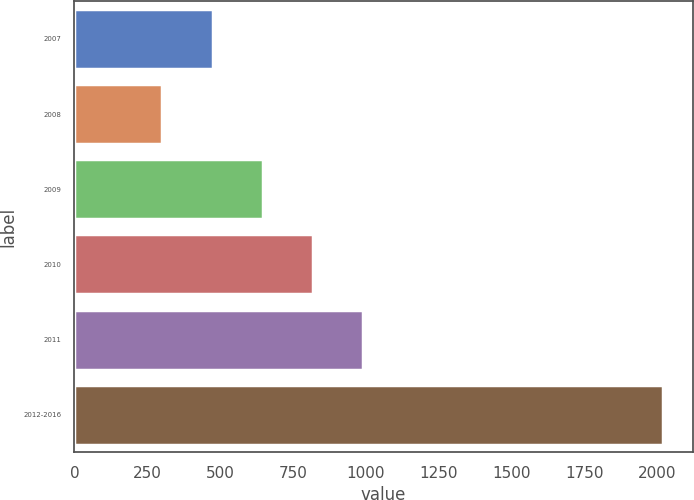<chart> <loc_0><loc_0><loc_500><loc_500><bar_chart><fcel>2007<fcel>2008<fcel>2009<fcel>2010<fcel>2011<fcel>2012-2016<nl><fcel>473.8<fcel>302<fcel>645.6<fcel>817.4<fcel>989.2<fcel>2020<nl></chart> 